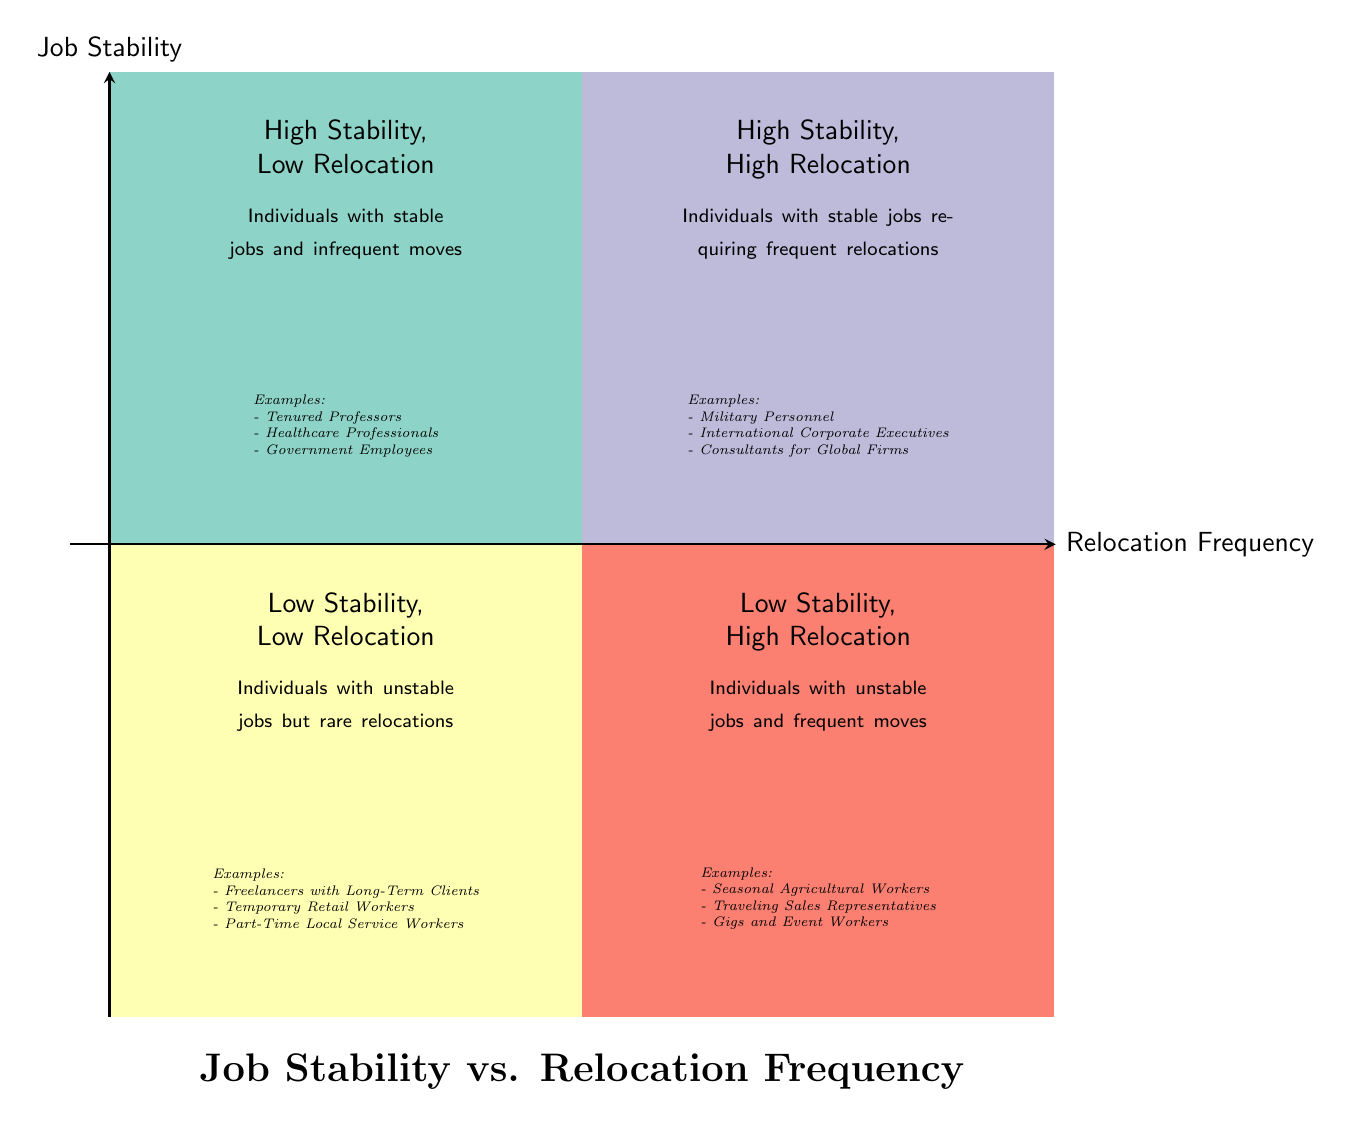What are the examples in the "High Stability, Low Relocation" quadrant? The "High Stability, Low Relocation" quadrant lists examples of individuals with stable jobs and infrequent moves, specifically Tenured Professors, Healthcare Professionals with Permanent Positions, and Government Employees.
Answer: Tenured Professors, Healthcare Professionals with Permanent Positions, Government Employees What quadrant contains individuals with unstable jobs and frequent moves? The description and examples for the "Low Stability, High Relocation" quadrant indicate that it is the quadrant where individuals with unstable jobs and frequent moves are categorized. The examples mentioned include Seasonal Agricultural Workers, Traveling Sales Representatives, and Gigs and Event Workers.
Answer: Low Stability, High Relocation How many quadrants are represented in the diagram? The diagram has four quadrants: High Stability, Low Relocation; Low Stability, Low Relocation; High Stability, High Relocation; and Low Stability, High Relocation, which can be counted directly from the diagram.
Answer: Four quadrants Which quadrant is described as having stable jobs requiring frequent relocations? The "High Stability, High Relocation" quadrant is defined as the one containing individuals holding stable jobs that necessitate frequent moves, as per the quadrant description.
Answer: High Stability, High Relocation What color represents the "Low Stability, Low Relocation" quadrant? The diagram uses the specific color code for the "Low Stability, Low Relocation" quadrant, which is shown as a light yellow (FFFFB3). This can be determined by identifying the colors associated with each quadrant in the diagram.
Answer: Light yellow Which examples belong to the "High Stability, High Relocation" quadrant? The examples listed under the "High Stability, High Relocation" quadrant include Military Personnel, International Corporate Executives, and Consultants for Global Firms, as indicated clearly in the quadrant's description section.
Answer: Military Personnel, International Corporate Executives, Consultants for Global Firms What is the description of the "Low Stability, Low Relocation" quadrant? The description for this quadrant explicitly states that it features individuals with unstable jobs but rare relocations. By reading the diagram's text associated with this quadrant, this information can be extracted directly.
Answer: Individuals with unstable jobs but rare relocations In which quadrant would you place Temporary Retail Workers? Temporary Retail Workers are placed in the "Low Stability, Low Relocation" quadrant, where the examples highlight jobs that are often not stable but do not require frequent relocations. The examples listed for that quadrant show this clearly.
Answer: Low Stability, Low Relocation 